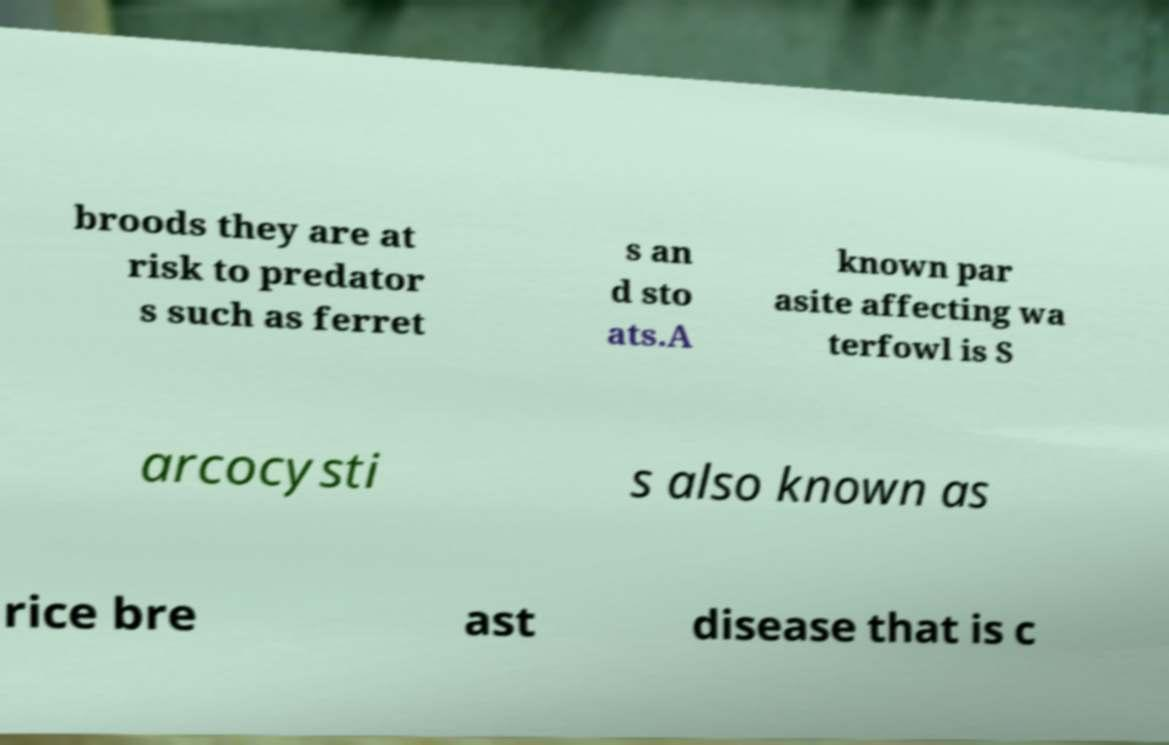I need the written content from this picture converted into text. Can you do that? broods they are at risk to predator s such as ferret s an d sto ats.A known par asite affecting wa terfowl is S arcocysti s also known as rice bre ast disease that is c 